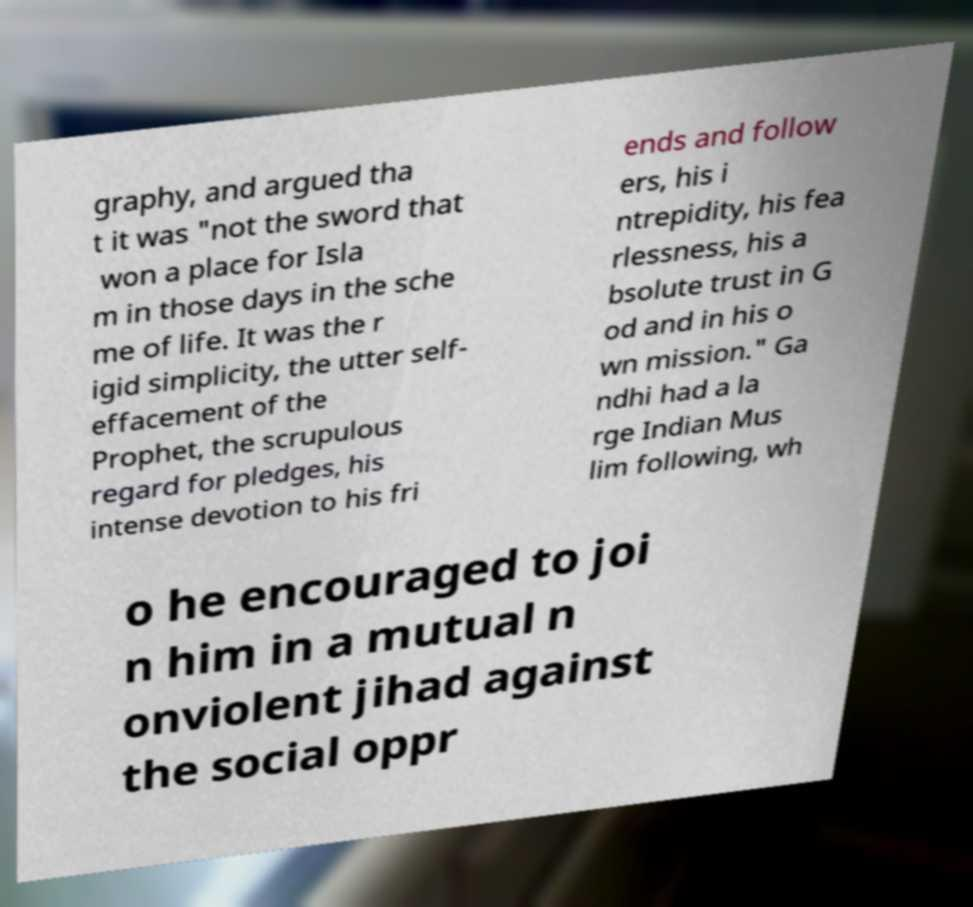I need the written content from this picture converted into text. Can you do that? graphy, and argued tha t it was "not the sword that won a place for Isla m in those days in the sche me of life. It was the r igid simplicity, the utter self- effacement of the Prophet, the scrupulous regard for pledges, his intense devotion to his fri ends and follow ers, his i ntrepidity, his fea rlessness, his a bsolute trust in G od and in his o wn mission." Ga ndhi had a la rge Indian Mus lim following, wh o he encouraged to joi n him in a mutual n onviolent jihad against the social oppr 